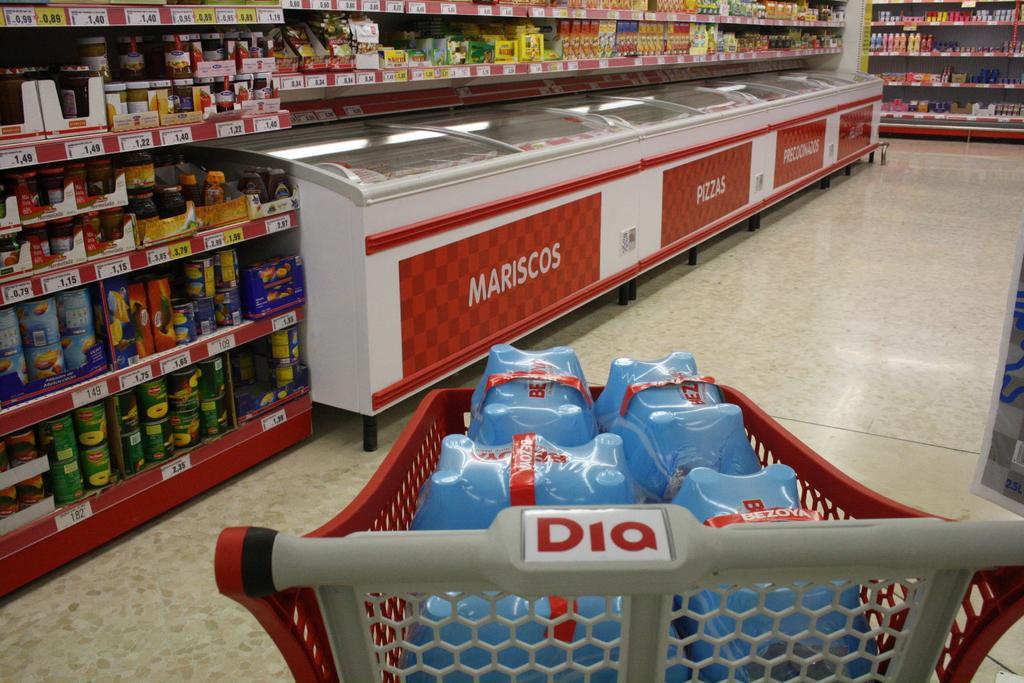<image>
Describe the image concisely. the letters DIQ that is on a carriage 